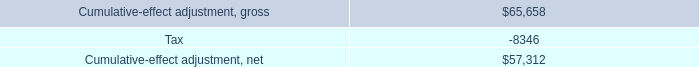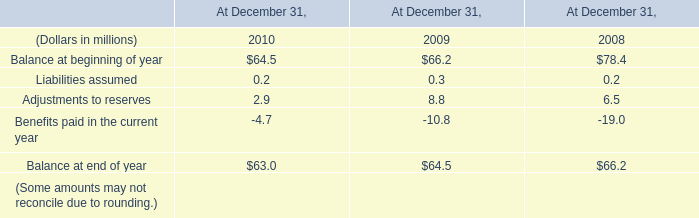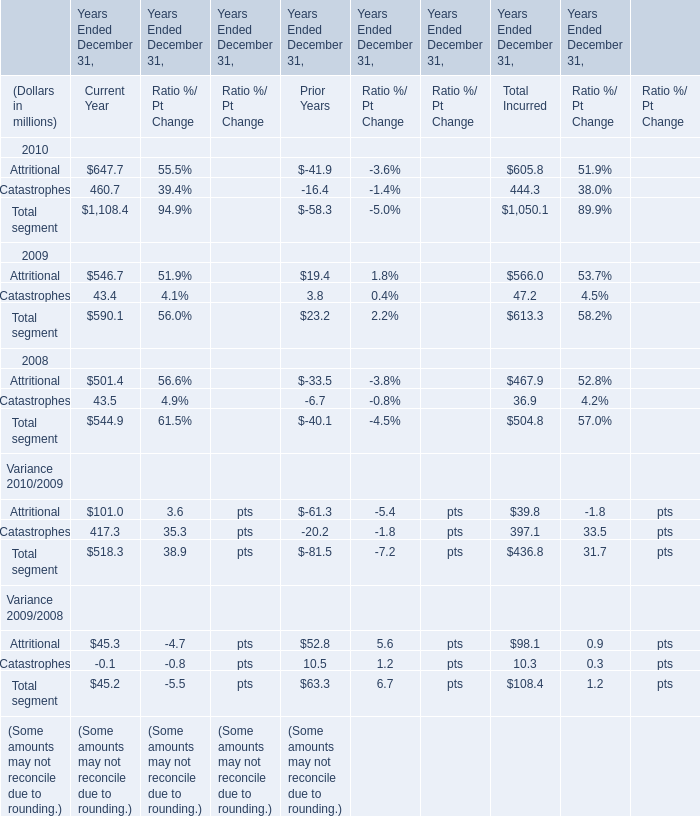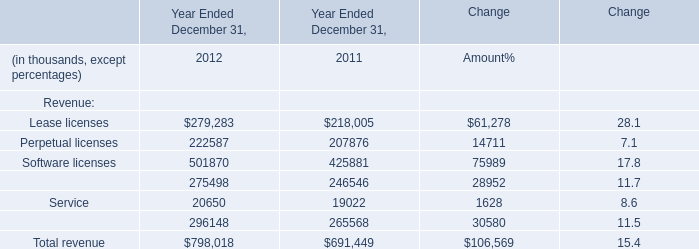What is the growing rate of Maintenance in the year with the most Service? 
Computations: ((275498 - 246546) / 246546)
Answer: 0.11743. 